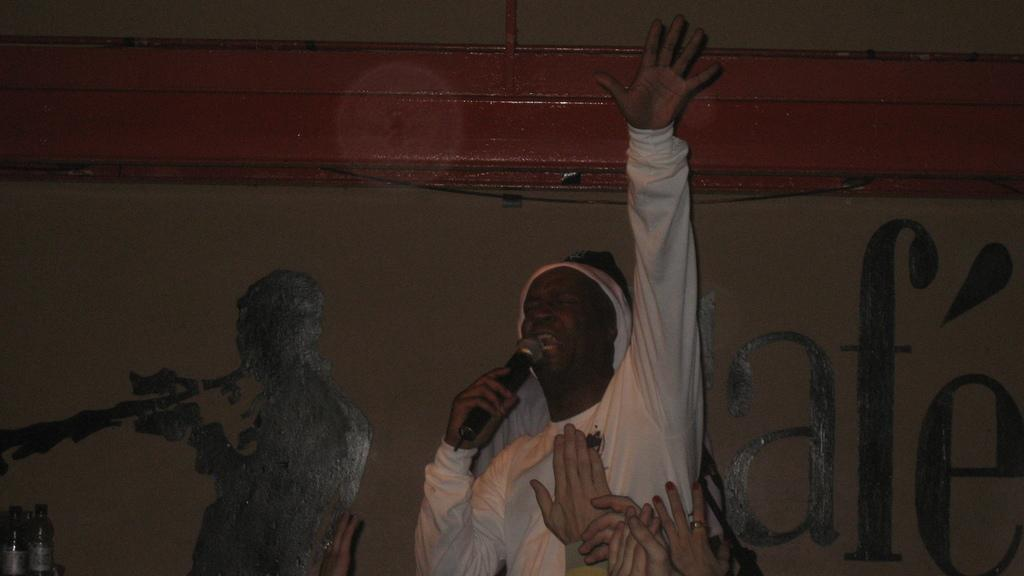Who or what is the main subject in the center of the image? There is a person in the center of the image. What is the person wearing? The person is wearing a white t-shirt. What is the person holding in their hand? The person is holding a mic. What can be seen behind the person in the image? There is a wall in the background of the image. Where is the desk located in the image? There is no desk present in the image. What type of lead is the person using to communicate in the image? The person is holding a mic, not a lead, for communication. 